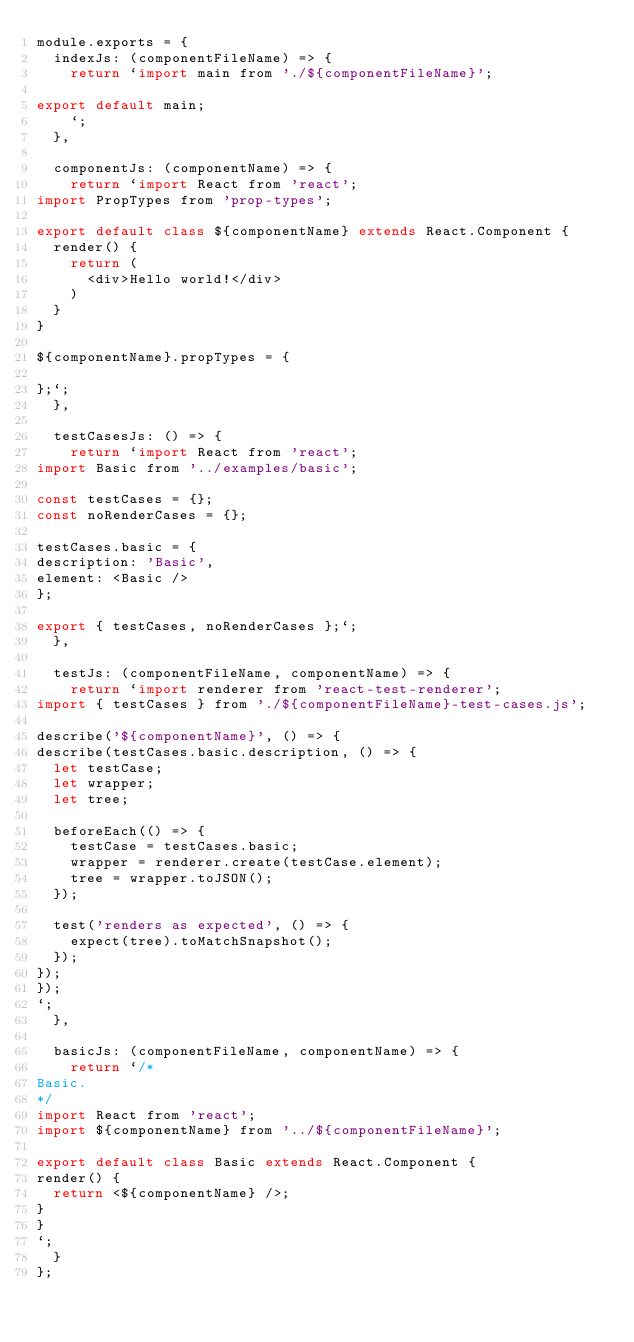<code> <loc_0><loc_0><loc_500><loc_500><_JavaScript_>module.exports = {
  indexJs: (componentFileName) => {
    return `import main from './${componentFileName}';

export default main;
    `;
  },

  componentJs: (componentName) => {
    return `import React from 'react';
import PropTypes from 'prop-types';

export default class ${componentName} extends React.Component {
  render() {
    return (
      <div>Hello world!</div>
    )
  }
}

${componentName}.propTypes = {

};`;
  },

  testCasesJs: () => {
    return `import React from 'react';
import Basic from '../examples/basic';

const testCases = {};
const noRenderCases = {};

testCases.basic = {
description: 'Basic',
element: <Basic />
};

export { testCases, noRenderCases };`;
  },

  testJs: (componentFileName, componentName) => {
    return `import renderer from 'react-test-renderer';
import { testCases } from './${componentFileName}-test-cases.js';

describe('${componentName}', () => {
describe(testCases.basic.description, () => {
  let testCase;
  let wrapper;
  let tree;

  beforeEach(() => {
    testCase = testCases.basic;
    wrapper = renderer.create(testCase.element);
    tree = wrapper.toJSON();
  });

  test('renders as expected', () => {
    expect(tree).toMatchSnapshot();
  });
});
});
`;
  },

  basicJs: (componentFileName, componentName) => {
    return `/*
Basic.
*/
import React from 'react';
import ${componentName} from '../${componentFileName}';

export default class Basic extends React.Component {
render() {
  return <${componentName} />;
}
}
`;
  }
};
</code> 